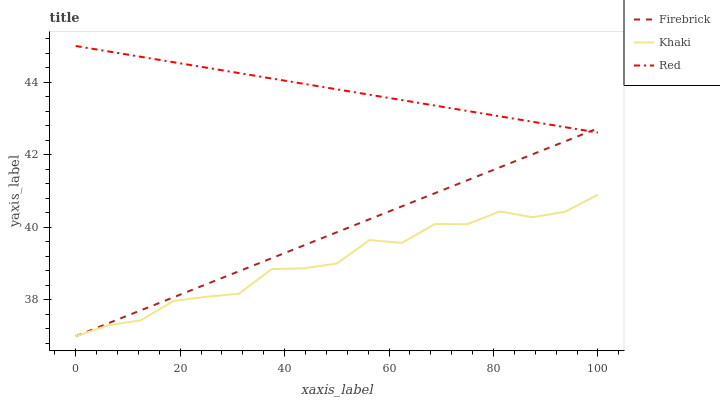Does Red have the minimum area under the curve?
Answer yes or no. No. Does Khaki have the maximum area under the curve?
Answer yes or no. No. Is Khaki the smoothest?
Answer yes or no. No. Is Red the roughest?
Answer yes or no. No. Does Red have the lowest value?
Answer yes or no. No. Does Khaki have the highest value?
Answer yes or no. No. Is Khaki less than Red?
Answer yes or no. Yes. Is Red greater than Khaki?
Answer yes or no. Yes. Does Khaki intersect Red?
Answer yes or no. No. 